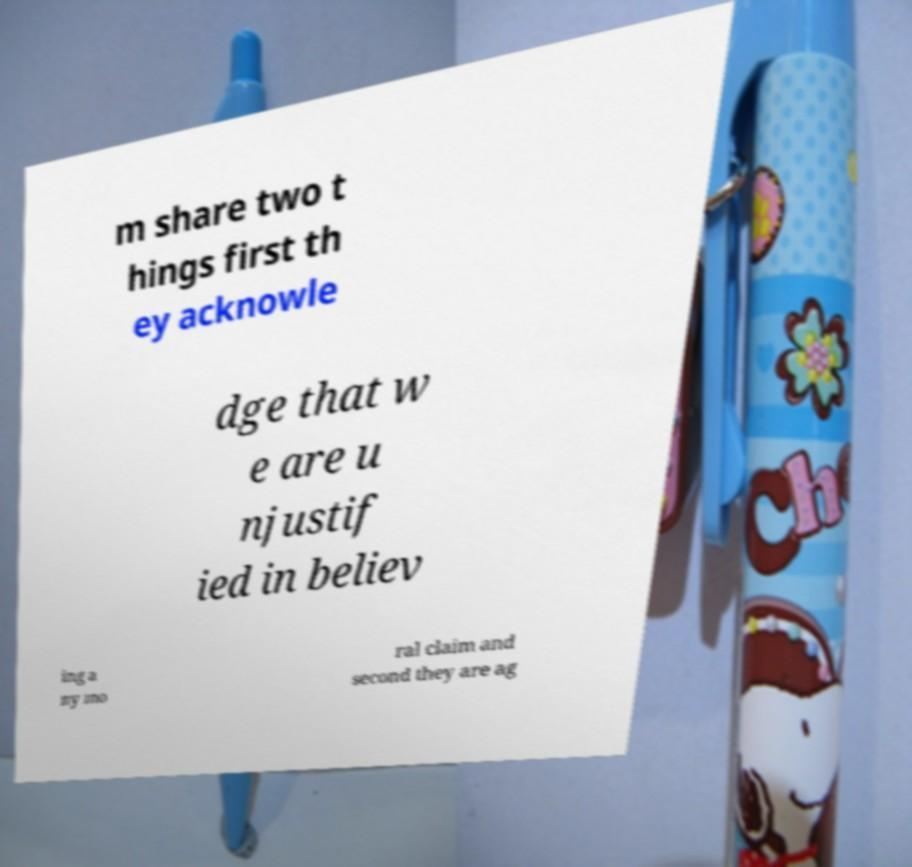Could you assist in decoding the text presented in this image and type it out clearly? m share two t hings first th ey acknowle dge that w e are u njustif ied in believ ing a ny mo ral claim and second they are ag 